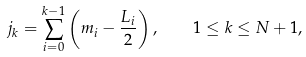<formula> <loc_0><loc_0><loc_500><loc_500>j _ { k } = \sum _ { i = 0 } ^ { k - 1 } \left ( m _ { i } - \frac { L _ { i } } { 2 } \right ) , \quad 1 \leq k \leq N + 1 ,</formula> 